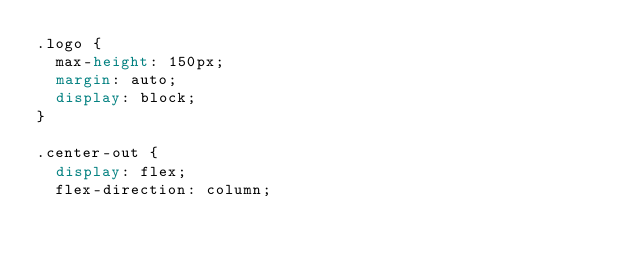<code> <loc_0><loc_0><loc_500><loc_500><_CSS_>.logo {
  max-height: 150px;
  margin: auto;
  display: block;
}

.center-out {
  display: flex;
  flex-direction: column;</code> 